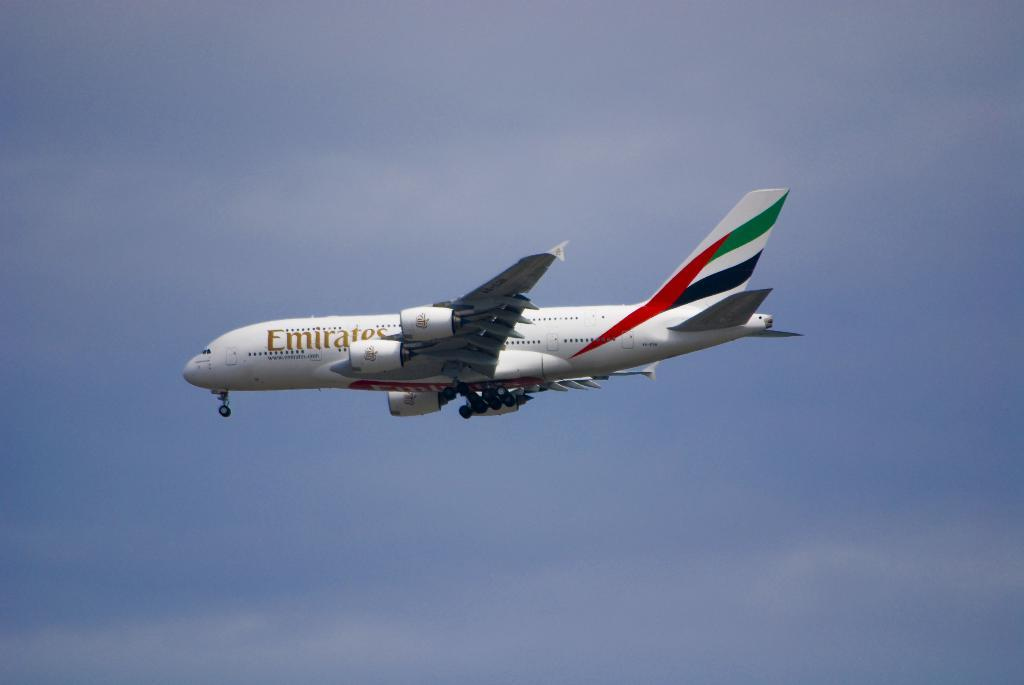What is the main subject of the image? There is an Emirates airplane in the center of the image. What can be seen in the background of the image? The sky is visible in the background of the image. What type of metal is the airplane made of in the image? The image does not provide information about the type of metal used to construct the airplane. 